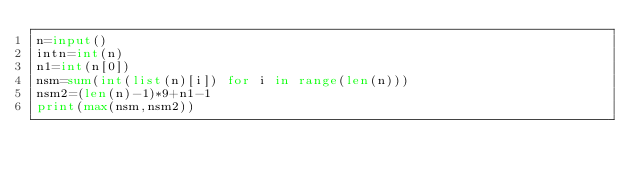<code> <loc_0><loc_0><loc_500><loc_500><_Python_>n=input()
intn=int(n)
n1=int(n[0])
nsm=sum(int(list(n)[i]) for i in range(len(n)))
nsm2=(len(n)-1)*9+n1-1
print(max(nsm,nsm2))</code> 